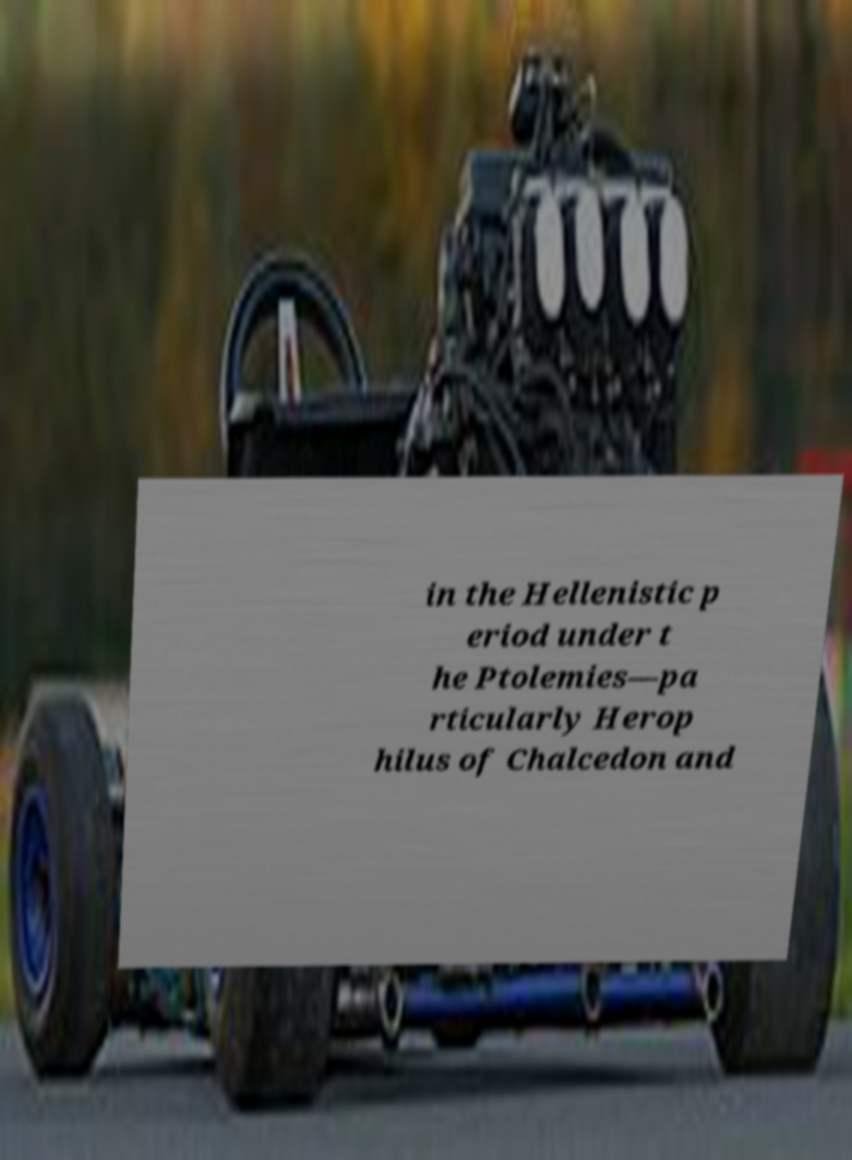What messages or text are displayed in this image? I need them in a readable, typed format. in the Hellenistic p eriod under t he Ptolemies—pa rticularly Herop hilus of Chalcedon and 